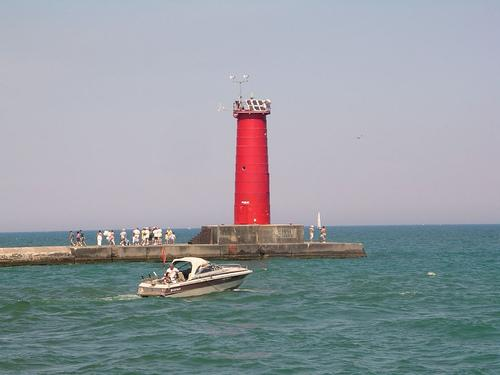How did the people standing near the lighthouse structure arrive here? boat 